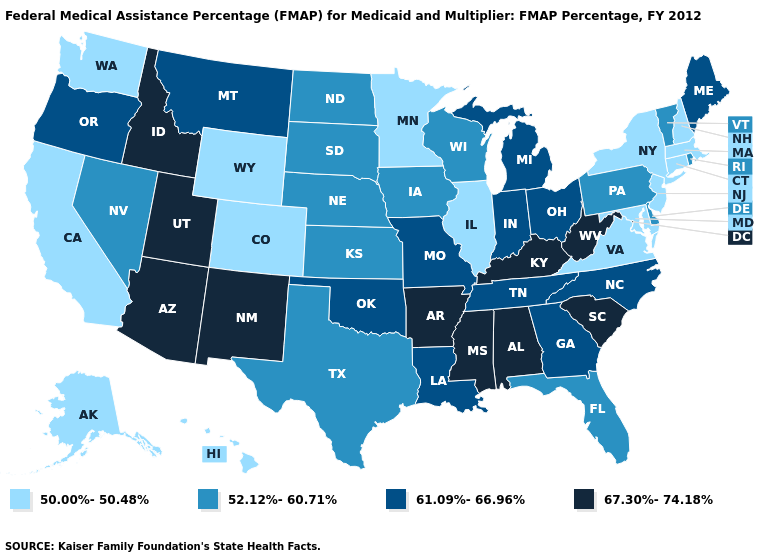What is the value of Alaska?
Concise answer only. 50.00%-50.48%. What is the value of Minnesota?
Be succinct. 50.00%-50.48%. What is the value of California?
Be succinct. 50.00%-50.48%. What is the lowest value in the USA?
Quick response, please. 50.00%-50.48%. Does Alaska have a higher value than Utah?
Keep it brief. No. Name the states that have a value in the range 52.12%-60.71%?
Answer briefly. Delaware, Florida, Iowa, Kansas, Nebraska, Nevada, North Dakota, Pennsylvania, Rhode Island, South Dakota, Texas, Vermont, Wisconsin. Name the states that have a value in the range 67.30%-74.18%?
Answer briefly. Alabama, Arizona, Arkansas, Idaho, Kentucky, Mississippi, New Mexico, South Carolina, Utah, West Virginia. What is the lowest value in the MidWest?
Be succinct. 50.00%-50.48%. What is the lowest value in the West?
Be succinct. 50.00%-50.48%. Does Michigan have a higher value than Illinois?
Quick response, please. Yes. What is the value of Kentucky?
Quick response, please. 67.30%-74.18%. Among the states that border Michigan , which have the highest value?
Be succinct. Indiana, Ohio. What is the value of West Virginia?
Concise answer only. 67.30%-74.18%. Does the map have missing data?
Quick response, please. No. Which states have the lowest value in the USA?
Answer briefly. Alaska, California, Colorado, Connecticut, Hawaii, Illinois, Maryland, Massachusetts, Minnesota, New Hampshire, New Jersey, New York, Virginia, Washington, Wyoming. 